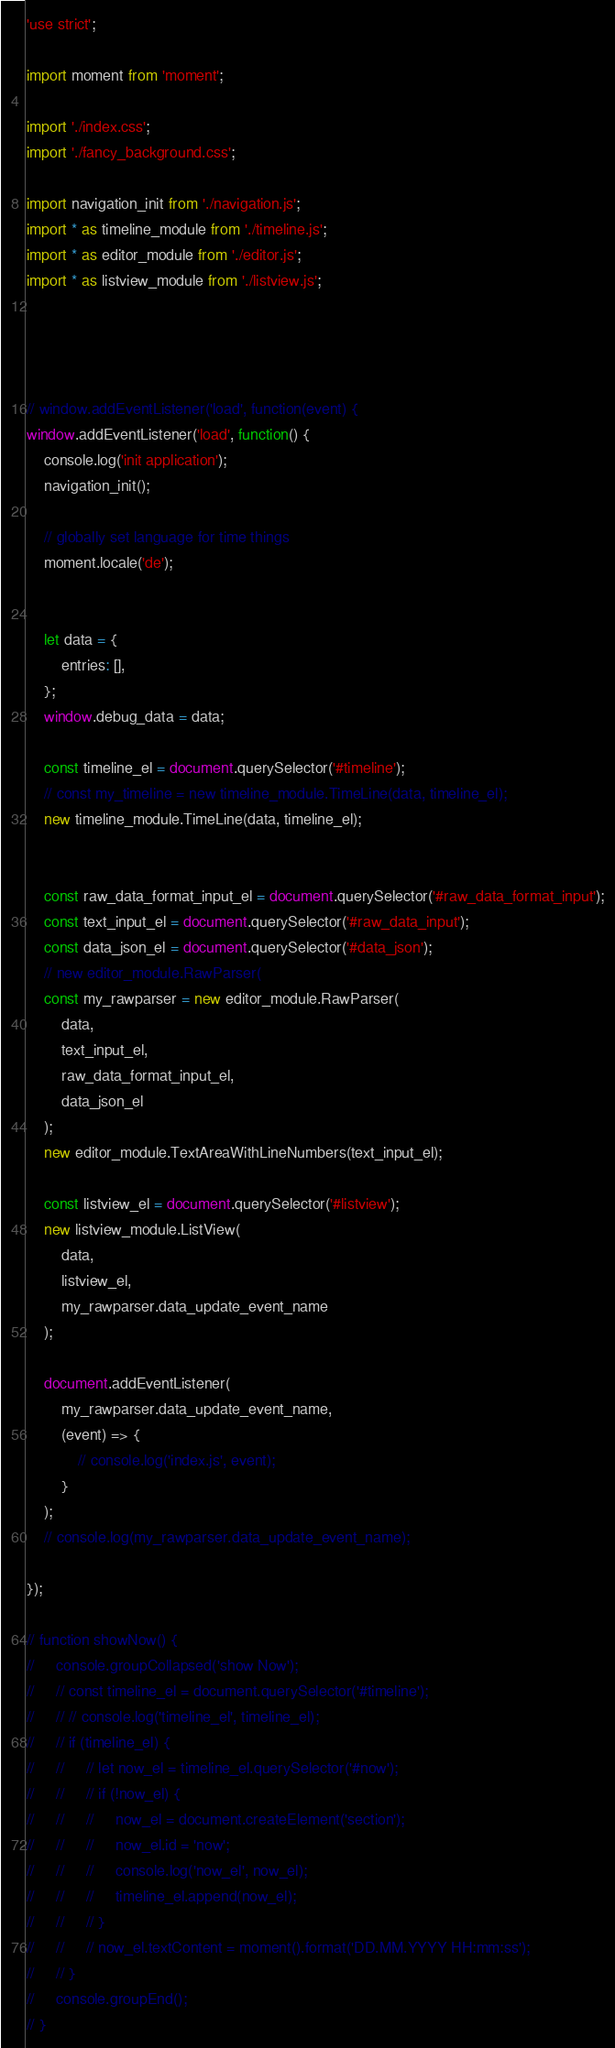Convert code to text. <code><loc_0><loc_0><loc_500><loc_500><_JavaScript_>'use strict';

import moment from 'moment';

import './index.css';
import './fancy_background.css';

import navigation_init from './navigation.js';
import * as timeline_module from './timeline.js';
import * as editor_module from './editor.js';
import * as listview_module from './listview.js';




// window.addEventListener('load', function(event) {
window.addEventListener('load', function() {
    console.log('init application');
    navigation_init();

    // globally set language for time things
    moment.locale('de');


    let data = {
        entries: [],
    };
    window.debug_data = data;

    const timeline_el = document.querySelector('#timeline');
    // const my_timeline = new timeline_module.TimeLine(data, timeline_el);
    new timeline_module.TimeLine(data, timeline_el);


    const raw_data_format_input_el = document.querySelector('#raw_data_format_input');
    const text_input_el = document.querySelector('#raw_data_input');
    const data_json_el = document.querySelector('#data_json');
    // new editor_module.RawParser(
    const my_rawparser = new editor_module.RawParser(
        data,
        text_input_el,
        raw_data_format_input_el,
        data_json_el
    );
    new editor_module.TextAreaWithLineNumbers(text_input_el);

    const listview_el = document.querySelector('#listview');
    new listview_module.ListView(
        data,
        listview_el,
        my_rawparser.data_update_event_name
    );

    document.addEventListener(
        my_rawparser.data_update_event_name,
        (event) => {
            // console.log('index.js', event);
        }
    );
    // console.log(my_rawparser.data_update_event_name);

});

// function showNow() {
//     console.groupCollapsed('show Now');
//     // const timeline_el = document.querySelector('#timeline');
//     // // console.log('timeline_el', timeline_el);
//     // if (timeline_el) {
//     //     // let now_el = timeline_el.querySelector('#now');
//     //     // if (!now_el) {
//     //     //     now_el = document.createElement('section');
//     //     //     now_el.id = 'now';
//     //     //     console.log('now_el', now_el);
//     //     //     timeline_el.append(now_el);
//     //     // }
//     //     // now_el.textContent = moment().format('DD.MM.YYYY HH:mm:ss');
//     // }
//     console.groupEnd();
// }
</code> 